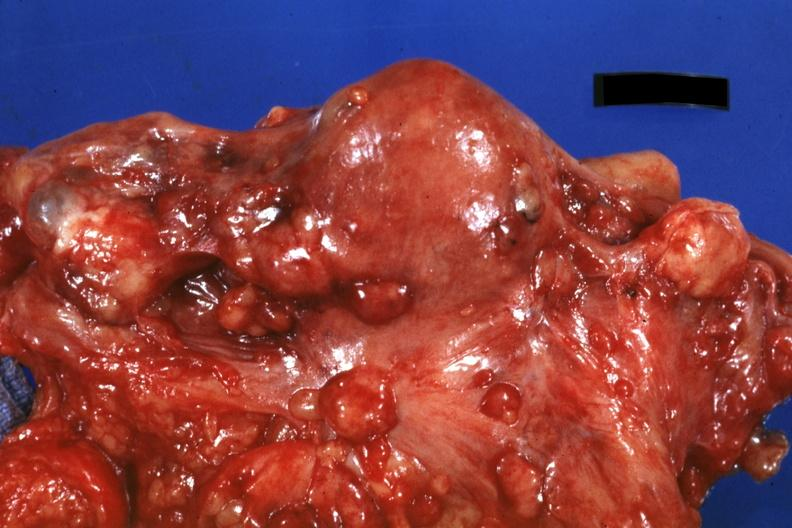what does this image show?
Answer the question using a single word or phrase. Close-up of uterus and ovaries with metastatic carcinoma on peritoneal surface 